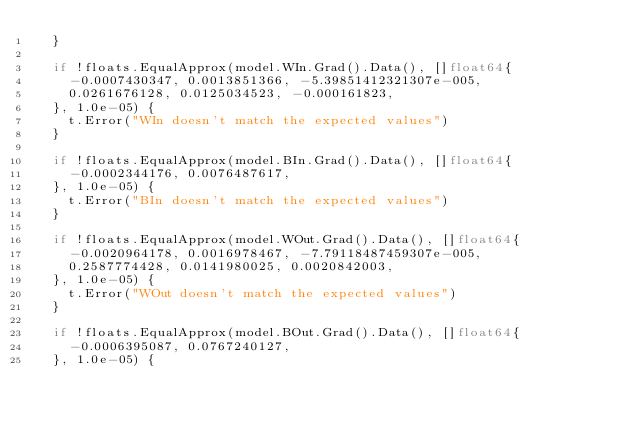Convert code to text. <code><loc_0><loc_0><loc_500><loc_500><_Go_>	}

	if !floats.EqualApprox(model.WIn.Grad().Data(), []float64{
		-0.0007430347, 0.0013851366, -5.39851412321307e-005,
		0.0261676128, 0.0125034523, -0.000161823,
	}, 1.0e-05) {
		t.Error("WIn doesn't match the expected values")
	}

	if !floats.EqualApprox(model.BIn.Grad().Data(), []float64{
		-0.0002344176, 0.0076487617,
	}, 1.0e-05) {
		t.Error("BIn doesn't match the expected values")
	}

	if !floats.EqualApprox(model.WOut.Grad().Data(), []float64{
		-0.0020964178, 0.0016978467, -7.79118487459307e-005,
		0.2587774428, 0.0141980025, 0.0020842003,
	}, 1.0e-05) {
		t.Error("WOut doesn't match the expected values")
	}

	if !floats.EqualApprox(model.BOut.Grad().Data(), []float64{
		-0.0006395087, 0.0767240127,
	}, 1.0e-05) {</code> 